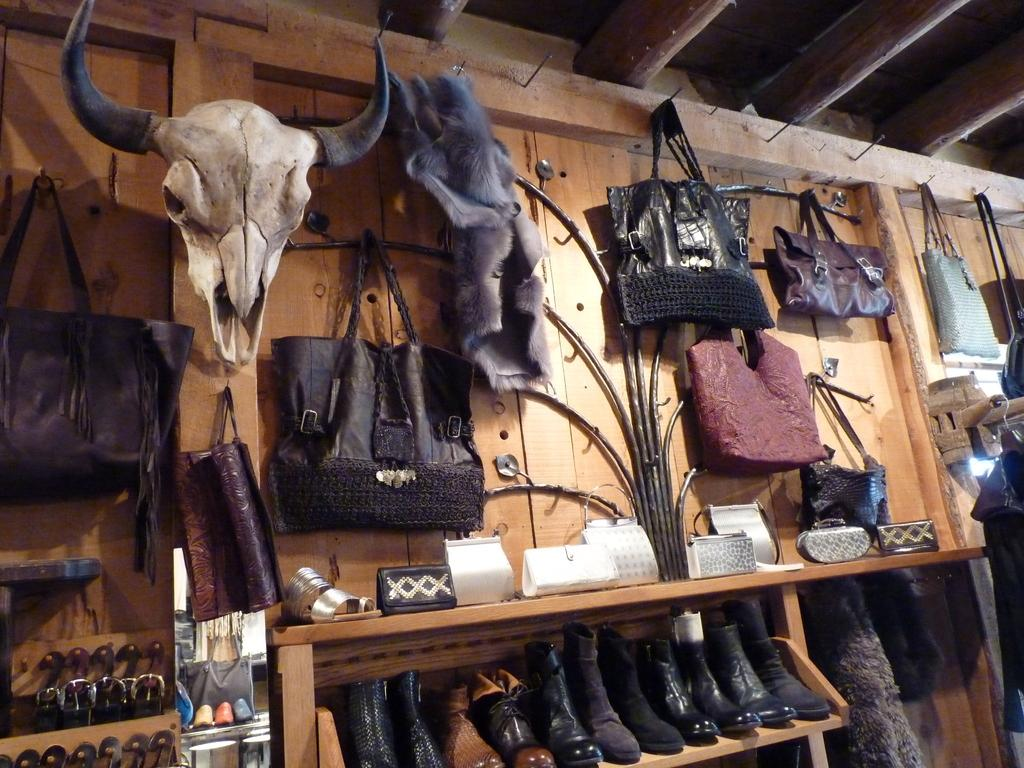What type of establishment is shown in the image? The image depicts a store. What type of products can be seen in the store? There are shoes, a handbag, and a purse in the image. Can you see a cart being used to transport the shoes in the image? There is no cart present in the image; the shoes are displayed on shelves or racks. 